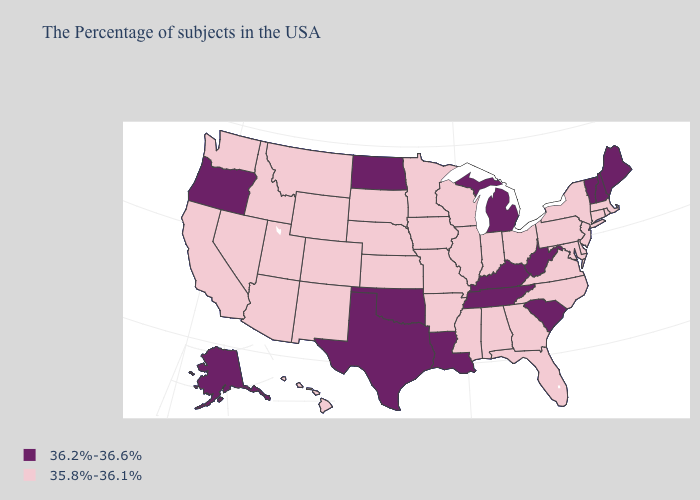Does Maine have the lowest value in the USA?
Be succinct. No. Name the states that have a value in the range 36.2%-36.6%?
Quick response, please. Maine, New Hampshire, Vermont, South Carolina, West Virginia, Michigan, Kentucky, Tennessee, Louisiana, Oklahoma, Texas, North Dakota, Oregon, Alaska. Name the states that have a value in the range 36.2%-36.6%?
Short answer required. Maine, New Hampshire, Vermont, South Carolina, West Virginia, Michigan, Kentucky, Tennessee, Louisiana, Oklahoma, Texas, North Dakota, Oregon, Alaska. Which states have the lowest value in the MidWest?
Be succinct. Ohio, Indiana, Wisconsin, Illinois, Missouri, Minnesota, Iowa, Kansas, Nebraska, South Dakota. What is the value of New Jersey?
Short answer required. 35.8%-36.1%. Which states have the lowest value in the USA?
Keep it brief. Massachusetts, Rhode Island, Connecticut, New York, New Jersey, Delaware, Maryland, Pennsylvania, Virginia, North Carolina, Ohio, Florida, Georgia, Indiana, Alabama, Wisconsin, Illinois, Mississippi, Missouri, Arkansas, Minnesota, Iowa, Kansas, Nebraska, South Dakota, Wyoming, Colorado, New Mexico, Utah, Montana, Arizona, Idaho, Nevada, California, Washington, Hawaii. How many symbols are there in the legend?
Write a very short answer. 2. What is the value of Alaska?
Write a very short answer. 36.2%-36.6%. Does North Carolina have the same value as Maine?
Write a very short answer. No. Name the states that have a value in the range 35.8%-36.1%?
Quick response, please. Massachusetts, Rhode Island, Connecticut, New York, New Jersey, Delaware, Maryland, Pennsylvania, Virginia, North Carolina, Ohio, Florida, Georgia, Indiana, Alabama, Wisconsin, Illinois, Mississippi, Missouri, Arkansas, Minnesota, Iowa, Kansas, Nebraska, South Dakota, Wyoming, Colorado, New Mexico, Utah, Montana, Arizona, Idaho, Nevada, California, Washington, Hawaii. What is the value of Delaware?
Short answer required. 35.8%-36.1%. What is the value of Washington?
Answer briefly. 35.8%-36.1%. What is the value of New Jersey?
Be succinct. 35.8%-36.1%. How many symbols are there in the legend?
Answer briefly. 2. Name the states that have a value in the range 35.8%-36.1%?
Write a very short answer. Massachusetts, Rhode Island, Connecticut, New York, New Jersey, Delaware, Maryland, Pennsylvania, Virginia, North Carolina, Ohio, Florida, Georgia, Indiana, Alabama, Wisconsin, Illinois, Mississippi, Missouri, Arkansas, Minnesota, Iowa, Kansas, Nebraska, South Dakota, Wyoming, Colorado, New Mexico, Utah, Montana, Arizona, Idaho, Nevada, California, Washington, Hawaii. 